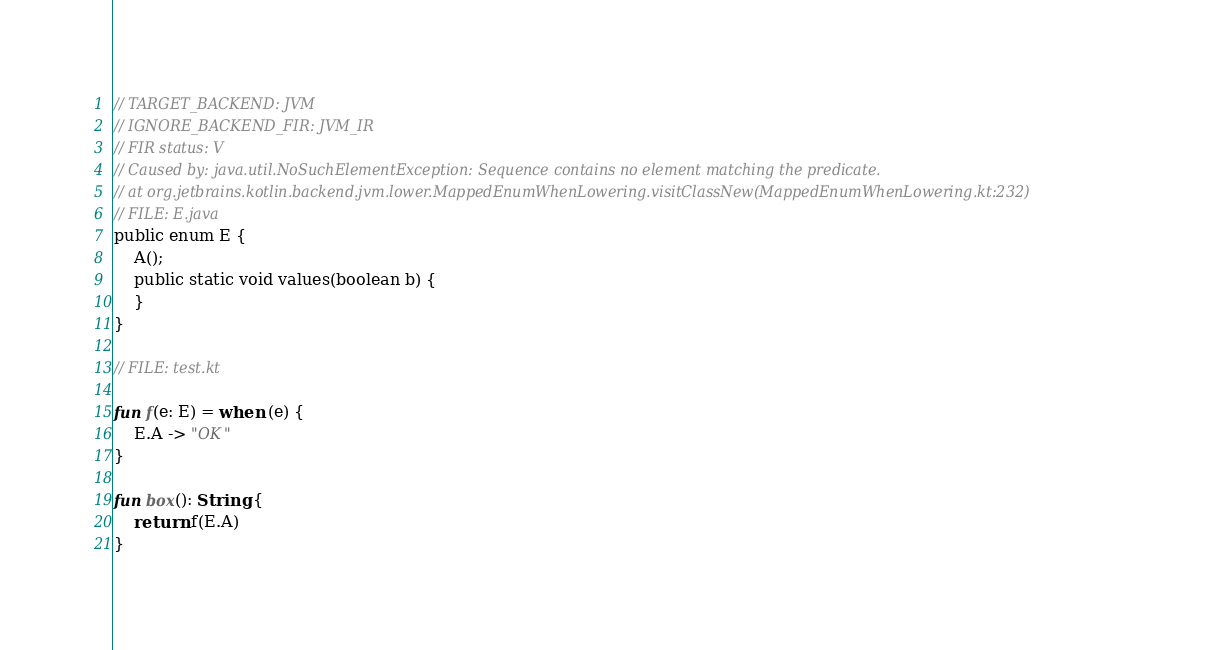Convert code to text. <code><loc_0><loc_0><loc_500><loc_500><_Kotlin_>// TARGET_BACKEND: JVM
// IGNORE_BACKEND_FIR: JVM_IR
// FIR status: V
// Caused by: java.util.NoSuchElementException: Sequence contains no element matching the predicate.
// at org.jetbrains.kotlin.backend.jvm.lower.MappedEnumWhenLowering.visitClassNew(MappedEnumWhenLowering.kt:232)
// FILE: E.java
public enum E {
    A();
    public static void values(boolean b) {
    }
}

// FILE: test.kt

fun f(e: E) = when (e) {
    E.A -> "OK"
}

fun box(): String {
    return f(E.A)
}
</code> 